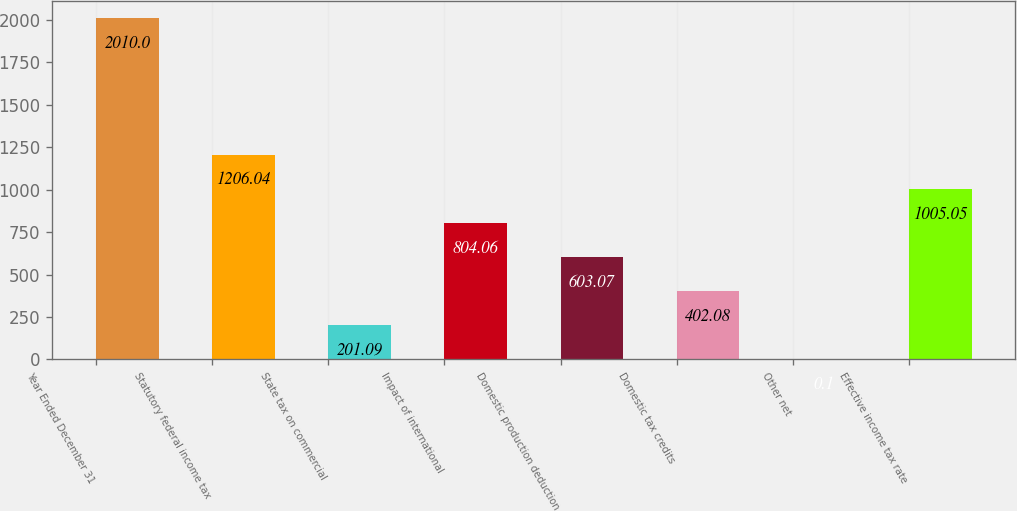Convert chart to OTSL. <chart><loc_0><loc_0><loc_500><loc_500><bar_chart><fcel>Year Ended December 31<fcel>Statutory federal income tax<fcel>State tax on commercial<fcel>Impact of international<fcel>Domestic production deduction<fcel>Domestic tax credits<fcel>Other net<fcel>Effective income tax rate<nl><fcel>2010<fcel>1206.04<fcel>201.09<fcel>804.06<fcel>603.07<fcel>402.08<fcel>0.1<fcel>1005.05<nl></chart> 